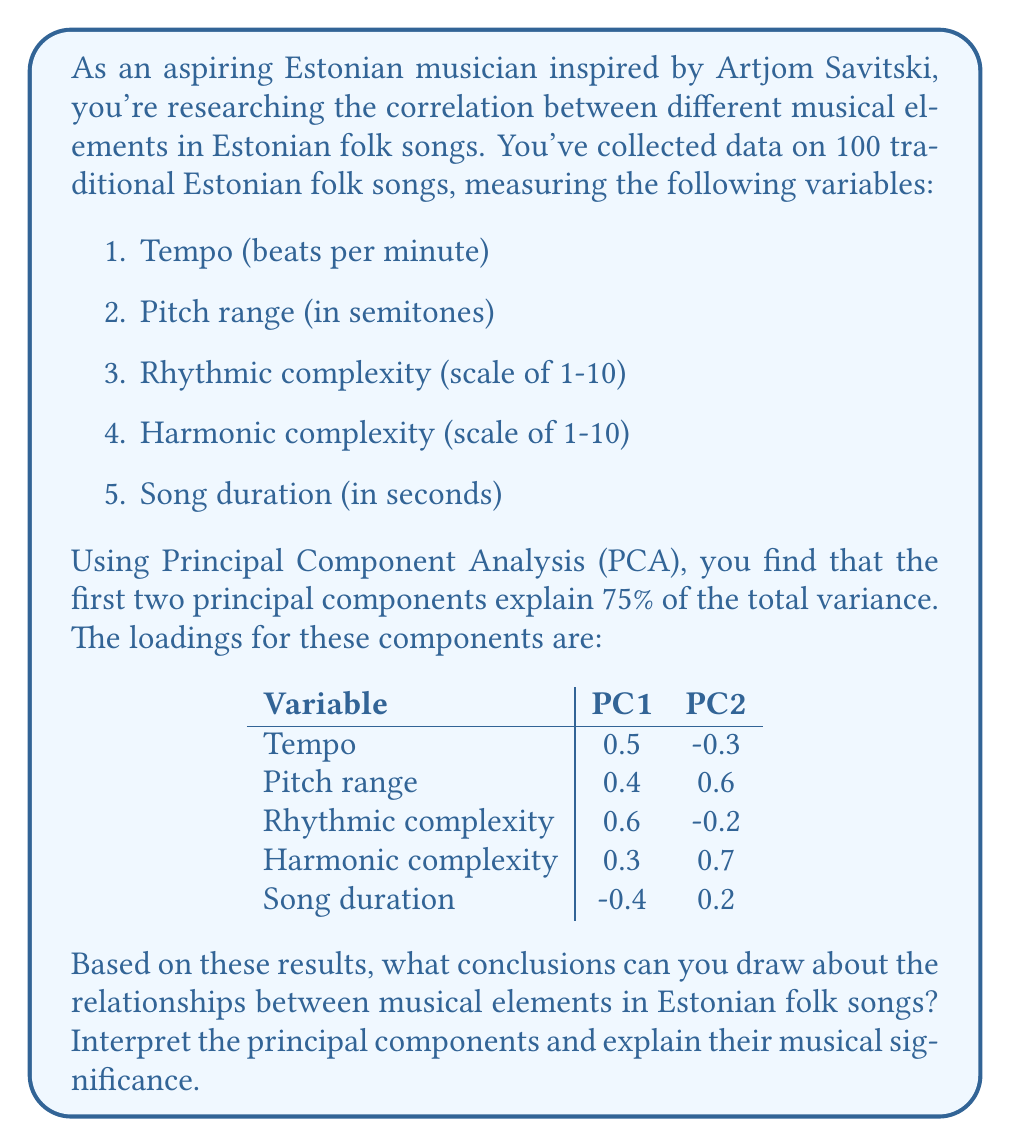Solve this math problem. To interpret the results of the Principal Component Analysis (PCA), we need to examine the loadings for each principal component and consider their musical significance. Let's break down the analysis step-by-step:

1. Understanding PCA:
   PCA is a technique used to reduce the dimensionality of a dataset while retaining as much variation as possible. Each principal component is a linear combination of the original variables, with the first component explaining the most variance, the second component explaining the second most, and so on.

2. Variance explained:
   The first two principal components explain 75% of the total variance, which means they capture a significant portion of the information in the dataset.

3. Interpreting PC1:
   PC1 has the following notable loadings:
   - Positive loadings: Tempo (0.5), Pitch range (0.4), Rhythmic complexity (0.6), Harmonic complexity (0.3)
   - Negative loading: Song duration (-0.4)

   This suggests that PC1 represents a contrast between songs with higher tempo, wider pitch range, and greater rhythmic and harmonic complexity versus longer songs. We could interpret this as a "complexity vs. length" component.

4. Interpreting PC2:
   PC2 has the following notable loadings:
   - Positive loadings: Pitch range (0.6), Harmonic complexity (0.7)
   - Negative loading: Tempo (-0.3)

   This suggests that PC2 represents songs with wider pitch ranges and greater harmonic complexity, but slightly slower tempos. We could interpret this as a "melodic-harmonic richness" component.

5. Musical significance:
   - PC1 suggests that in Estonian folk songs, there's a trade-off between musical complexity and song duration. More complex songs (in terms of tempo, rhythm, and pitch range) tend to be shorter, while longer songs tend to be simpler.
   - PC2 indicates that there's a subset of songs that focus on melodic and harmonic richness, characterized by wide pitch ranges and complex harmonies, but with slightly slower tempos.

6. Relationships between musical elements:
   - Tempo and rhythmic complexity are positively correlated (both have high positive loadings in PC1).
   - Pitch range and harmonic complexity are positively correlated (both have high positive loadings in PC2).
   - Song duration is negatively correlated with tempo and rhythmic complexity (opposite signs in PC1).

These results provide insights into the structure and composition of Estonian folk songs, highlighting the relationships between different musical elements and the main dimensions of variation in the repertoire.
Answer: The PCA results reveal two main dimensions of variation in Estonian folk songs:

1. PC1: "Complexity vs. Length" - This component contrasts shorter, more complex songs (higher tempo, wider pitch range, greater rhythmic and harmonic complexity) with longer, simpler songs.

2. PC2: "Melodic-Harmonic Richness" - This component represents songs with wider pitch ranges and greater harmonic complexity, but slightly slower tempos.

Key relationships:
- Positive correlation between tempo and rhythmic complexity
- Positive correlation between pitch range and harmonic complexity
- Negative correlation between song duration and tempo/rhythmic complexity

These findings suggest that Estonian folk songs exhibit a trade-off between musical complexity and length, with a subset of songs focusing on melodic and harmonic richness. 